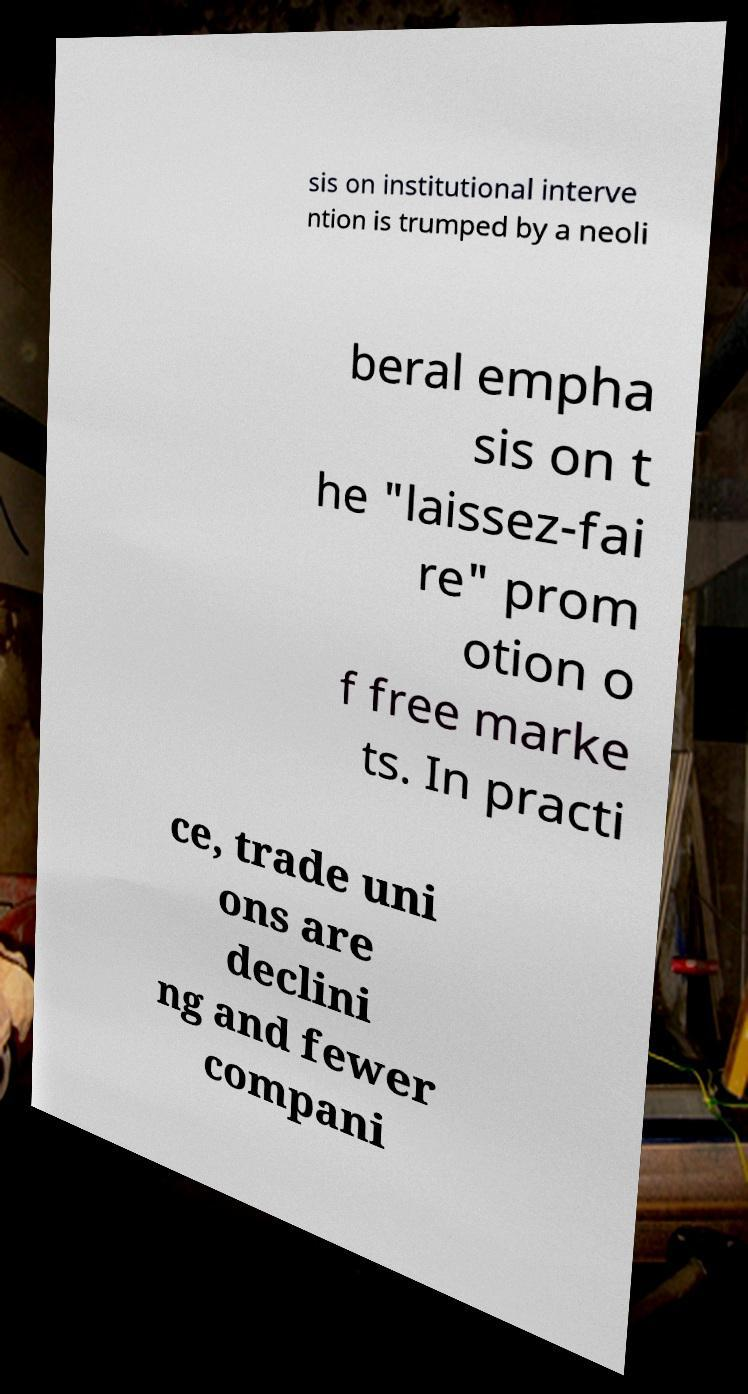Please read and relay the text visible in this image. What does it say? sis on institutional interve ntion is trumped by a neoli beral empha sis on t he "laissez-fai re" prom otion o f free marke ts. In practi ce, trade uni ons are declini ng and fewer compani 